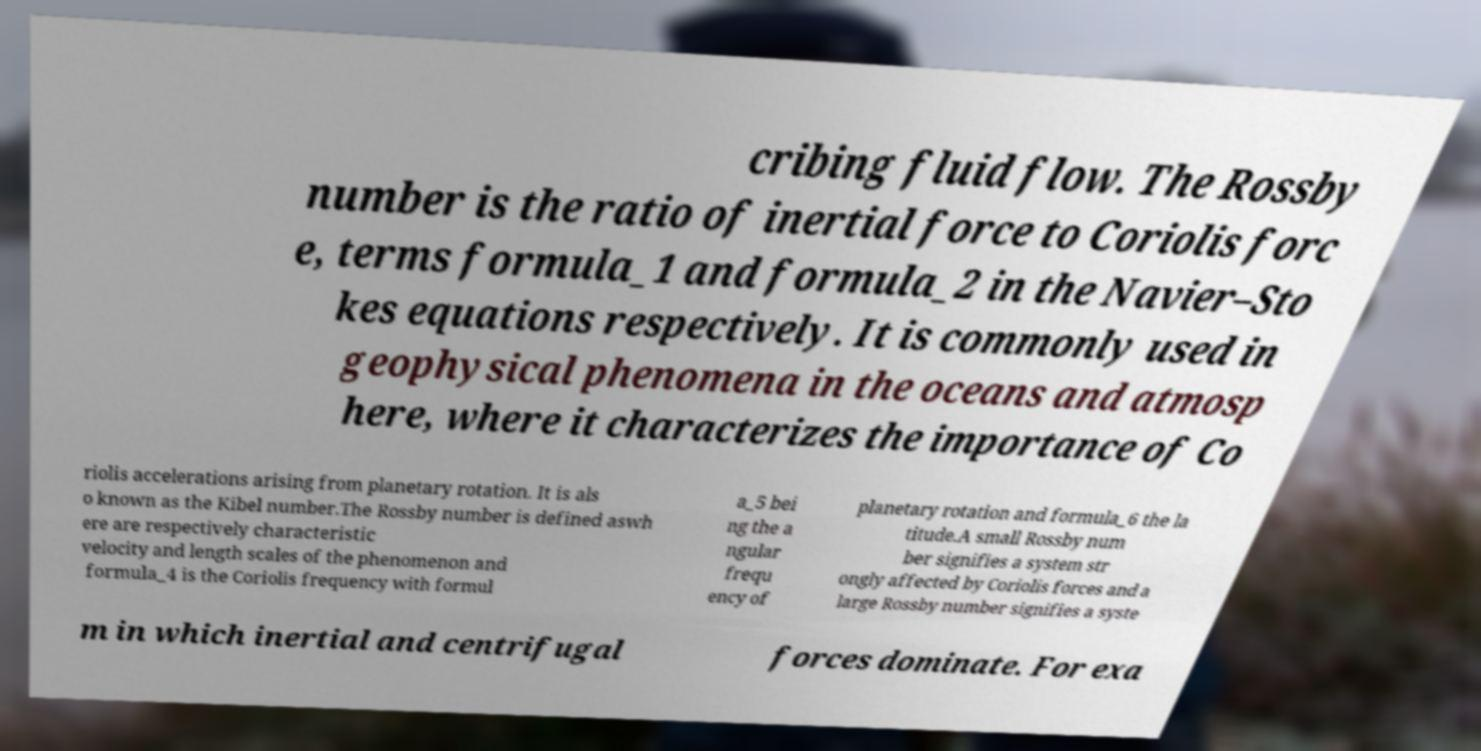Please read and relay the text visible in this image. What does it say? cribing fluid flow. The Rossby number is the ratio of inertial force to Coriolis forc e, terms formula_1 and formula_2 in the Navier–Sto kes equations respectively. It is commonly used in geophysical phenomena in the oceans and atmosp here, where it characterizes the importance of Co riolis accelerations arising from planetary rotation. It is als o known as the Kibel number.The Rossby number is defined aswh ere are respectively characteristic velocity and length scales of the phenomenon and formula_4 is the Coriolis frequency with formul a_5 bei ng the a ngular frequ ency of planetary rotation and formula_6 the la titude.A small Rossby num ber signifies a system str ongly affected by Coriolis forces and a large Rossby number signifies a syste m in which inertial and centrifugal forces dominate. For exa 